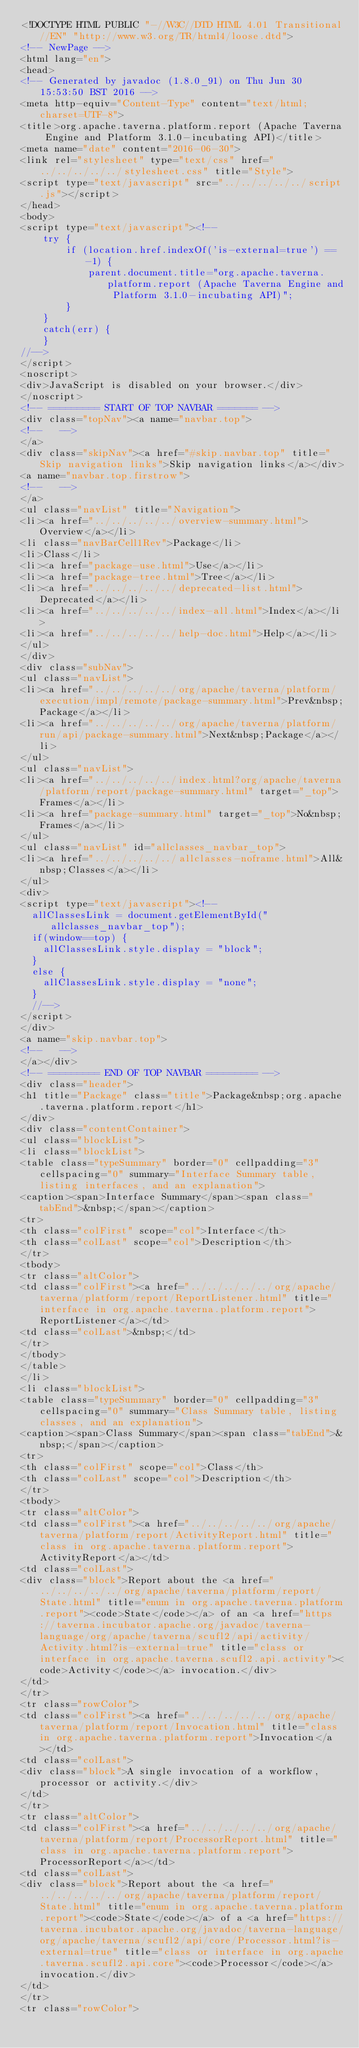<code> <loc_0><loc_0><loc_500><loc_500><_HTML_><!DOCTYPE HTML PUBLIC "-//W3C//DTD HTML 4.01 Transitional//EN" "http://www.w3.org/TR/html4/loose.dtd">
<!-- NewPage -->
<html lang="en">
<head>
<!-- Generated by javadoc (1.8.0_91) on Thu Jun 30 15:53:50 BST 2016 -->
<meta http-equiv="Content-Type" content="text/html; charset=UTF-8">
<title>org.apache.taverna.platform.report (Apache Taverna Engine and Platform 3.1.0-incubating API)</title>
<meta name="date" content="2016-06-30">
<link rel="stylesheet" type="text/css" href="../../../../../stylesheet.css" title="Style">
<script type="text/javascript" src="../../../../../script.js"></script>
</head>
<body>
<script type="text/javascript"><!--
    try {
        if (location.href.indexOf('is-external=true') == -1) {
            parent.document.title="org.apache.taverna.platform.report (Apache Taverna Engine and Platform 3.1.0-incubating API)";
        }
    }
    catch(err) {
    }
//-->
</script>
<noscript>
<div>JavaScript is disabled on your browser.</div>
</noscript>
<!-- ========= START OF TOP NAVBAR ======= -->
<div class="topNav"><a name="navbar.top">
<!--   -->
</a>
<div class="skipNav"><a href="#skip.navbar.top" title="Skip navigation links">Skip navigation links</a></div>
<a name="navbar.top.firstrow">
<!--   -->
</a>
<ul class="navList" title="Navigation">
<li><a href="../../../../../overview-summary.html">Overview</a></li>
<li class="navBarCell1Rev">Package</li>
<li>Class</li>
<li><a href="package-use.html">Use</a></li>
<li><a href="package-tree.html">Tree</a></li>
<li><a href="../../../../../deprecated-list.html">Deprecated</a></li>
<li><a href="../../../../../index-all.html">Index</a></li>
<li><a href="../../../../../help-doc.html">Help</a></li>
</ul>
</div>
<div class="subNav">
<ul class="navList">
<li><a href="../../../../../org/apache/taverna/platform/execution/impl/remote/package-summary.html">Prev&nbsp;Package</a></li>
<li><a href="../../../../../org/apache/taverna/platform/run/api/package-summary.html">Next&nbsp;Package</a></li>
</ul>
<ul class="navList">
<li><a href="../../../../../index.html?org/apache/taverna/platform/report/package-summary.html" target="_top">Frames</a></li>
<li><a href="package-summary.html" target="_top">No&nbsp;Frames</a></li>
</ul>
<ul class="navList" id="allclasses_navbar_top">
<li><a href="../../../../../allclasses-noframe.html">All&nbsp;Classes</a></li>
</ul>
<div>
<script type="text/javascript"><!--
  allClassesLink = document.getElementById("allclasses_navbar_top");
  if(window==top) {
    allClassesLink.style.display = "block";
  }
  else {
    allClassesLink.style.display = "none";
  }
  //-->
</script>
</div>
<a name="skip.navbar.top">
<!--   -->
</a></div>
<!-- ========= END OF TOP NAVBAR ========= -->
<div class="header">
<h1 title="Package" class="title">Package&nbsp;org.apache.taverna.platform.report</h1>
</div>
<div class="contentContainer">
<ul class="blockList">
<li class="blockList">
<table class="typeSummary" border="0" cellpadding="3" cellspacing="0" summary="Interface Summary table, listing interfaces, and an explanation">
<caption><span>Interface Summary</span><span class="tabEnd">&nbsp;</span></caption>
<tr>
<th class="colFirst" scope="col">Interface</th>
<th class="colLast" scope="col">Description</th>
</tr>
<tbody>
<tr class="altColor">
<td class="colFirst"><a href="../../../../../org/apache/taverna/platform/report/ReportListener.html" title="interface in org.apache.taverna.platform.report">ReportListener</a></td>
<td class="colLast">&nbsp;</td>
</tr>
</tbody>
</table>
</li>
<li class="blockList">
<table class="typeSummary" border="0" cellpadding="3" cellspacing="0" summary="Class Summary table, listing classes, and an explanation">
<caption><span>Class Summary</span><span class="tabEnd">&nbsp;</span></caption>
<tr>
<th class="colFirst" scope="col">Class</th>
<th class="colLast" scope="col">Description</th>
</tr>
<tbody>
<tr class="altColor">
<td class="colFirst"><a href="../../../../../org/apache/taverna/platform/report/ActivityReport.html" title="class in org.apache.taverna.platform.report">ActivityReport</a></td>
<td class="colLast">
<div class="block">Report about the <a href="../../../../../org/apache/taverna/platform/report/State.html" title="enum in org.apache.taverna.platform.report"><code>State</code></a> of an <a href="https://taverna.incubator.apache.org/javadoc/taverna-language/org/apache/taverna/scufl2/api/activity/Activity.html?is-external=true" title="class or interface in org.apache.taverna.scufl2.api.activity"><code>Activity</code></a> invocation.</div>
</td>
</tr>
<tr class="rowColor">
<td class="colFirst"><a href="../../../../../org/apache/taverna/platform/report/Invocation.html" title="class in org.apache.taverna.platform.report">Invocation</a></td>
<td class="colLast">
<div class="block">A single invocation of a workflow, processor or activity.</div>
</td>
</tr>
<tr class="altColor">
<td class="colFirst"><a href="../../../../../org/apache/taverna/platform/report/ProcessorReport.html" title="class in org.apache.taverna.platform.report">ProcessorReport</a></td>
<td class="colLast">
<div class="block">Report about the <a href="../../../../../org/apache/taverna/platform/report/State.html" title="enum in org.apache.taverna.platform.report"><code>State</code></a> of a <a href="https://taverna.incubator.apache.org/javadoc/taverna-language/org/apache/taverna/scufl2/api/core/Processor.html?is-external=true" title="class or interface in org.apache.taverna.scufl2.api.core"><code>Processor</code></a> invocation.</div>
</td>
</tr>
<tr class="rowColor"></code> 